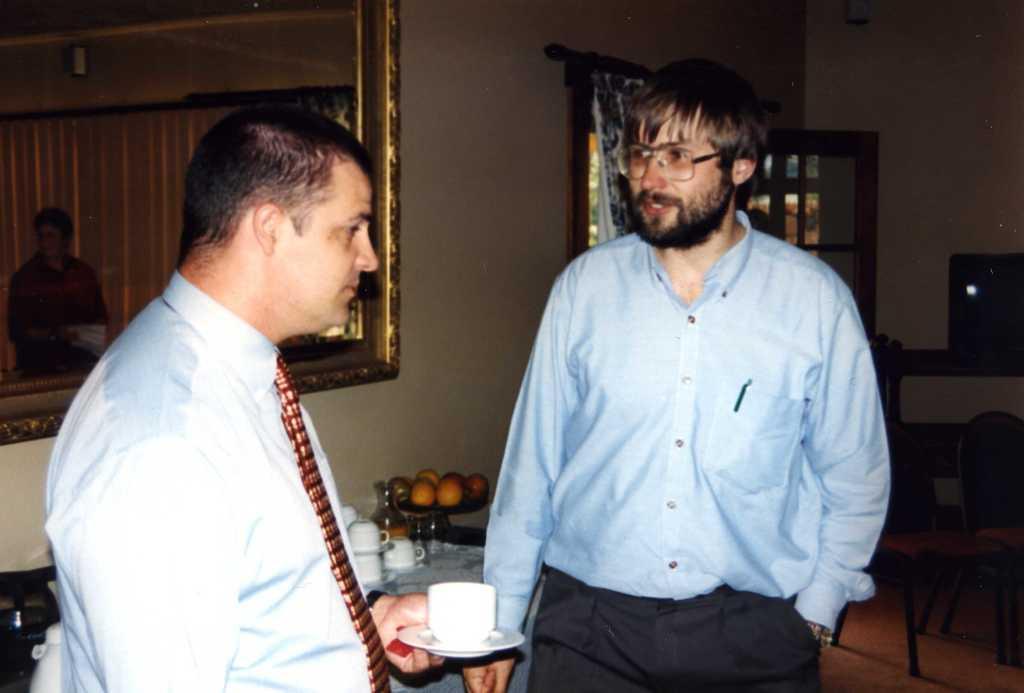Describe this image in one or two sentences. In the foreground of this image, there is a man standing, holding a cup and saucer and also another man putting hand in the pocket. In the background, there is a wall, mirror and cups, glass bottle, fruits and few objects on the table, a curtain, door, chairs and an object on the table. 